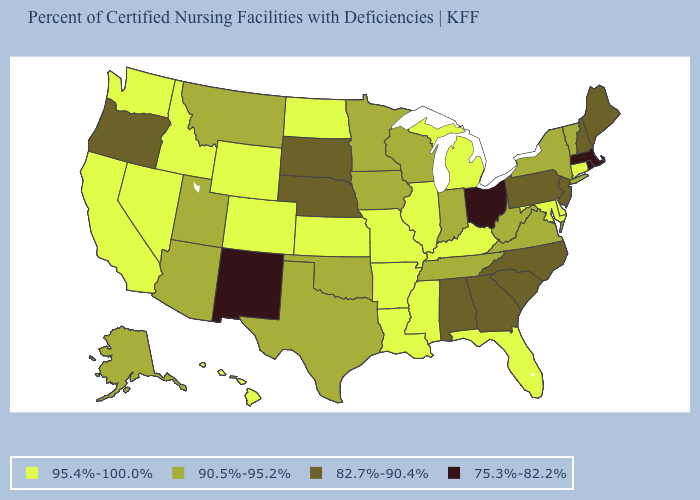What is the value of Wisconsin?
Write a very short answer. 90.5%-95.2%. Among the states that border Oklahoma , which have the highest value?
Short answer required. Arkansas, Colorado, Kansas, Missouri. Among the states that border Maryland , does Pennsylvania have the lowest value?
Answer briefly. Yes. What is the value of Montana?
Short answer required. 90.5%-95.2%. Does Oregon have the lowest value in the West?
Give a very brief answer. No. Which states have the lowest value in the USA?
Concise answer only. Massachusetts, New Mexico, Ohio, Rhode Island. What is the value of South Carolina?
Give a very brief answer. 82.7%-90.4%. Name the states that have a value in the range 95.4%-100.0%?
Write a very short answer. Arkansas, California, Colorado, Connecticut, Delaware, Florida, Hawaii, Idaho, Illinois, Kansas, Kentucky, Louisiana, Maryland, Michigan, Mississippi, Missouri, Nevada, North Dakota, Washington, Wyoming. Name the states that have a value in the range 82.7%-90.4%?
Keep it brief. Alabama, Georgia, Maine, Nebraska, New Hampshire, New Jersey, North Carolina, Oregon, Pennsylvania, South Carolina, South Dakota. What is the value of Florida?
Quick response, please. 95.4%-100.0%. Among the states that border Indiana , which have the lowest value?
Keep it brief. Ohio. Name the states that have a value in the range 82.7%-90.4%?
Write a very short answer. Alabama, Georgia, Maine, Nebraska, New Hampshire, New Jersey, North Carolina, Oregon, Pennsylvania, South Carolina, South Dakota. Among the states that border Louisiana , does Texas have the lowest value?
Give a very brief answer. Yes. What is the value of Georgia?
Answer briefly. 82.7%-90.4%. 